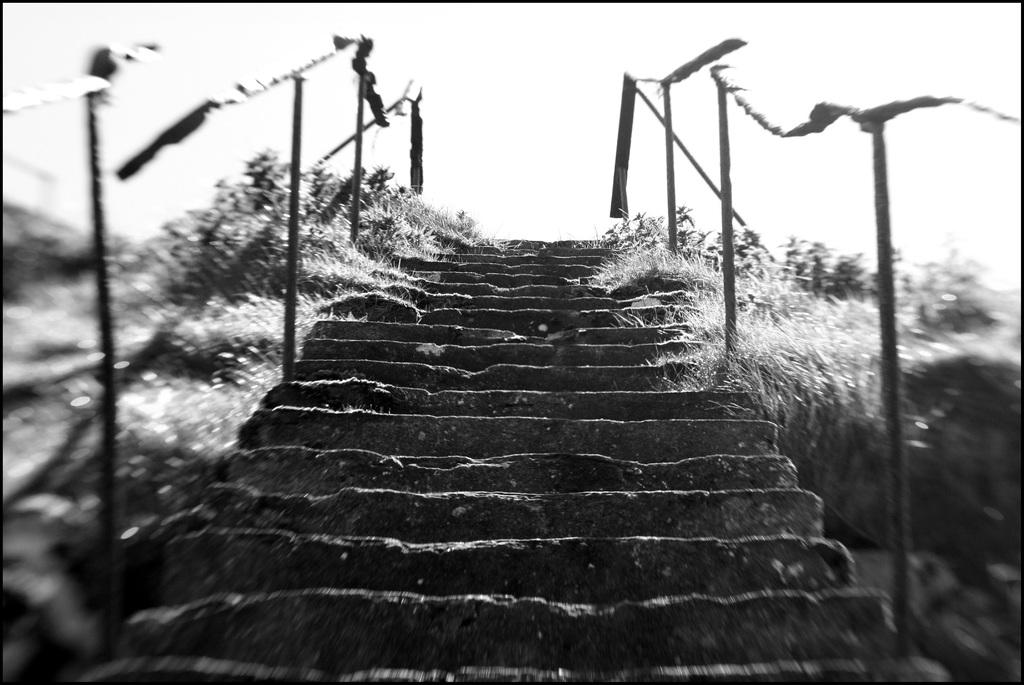What type of structure is present in the image? There are stairs in the image. Is there any safety feature associated with the stairs? Yes, there is a railing associated with the stairs. What type of vegetation can be seen on both sides of the image? There is grass on both the right and left sides of the image. What is visible at the top of the image? The sky is visible at the top of the image. What type of poisonous plant can be seen growing near the stairs in the image? There is no poisonous plant visible in the image; it only features stairs, a railing, grass, and the sky. What day of the week is depicted in the image? The image does not depict a specific day of the week; it only shows stairs, a railing, grass, and the sky. 